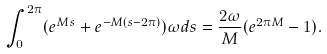Convert formula to latex. <formula><loc_0><loc_0><loc_500><loc_500>\int _ { 0 } ^ { 2 \pi } ( e ^ { M s } + e ^ { - M ( s - 2 \pi ) } ) \omega d s = \frac { 2 \omega } { M } ( e ^ { 2 \pi M } - 1 ) .</formula> 